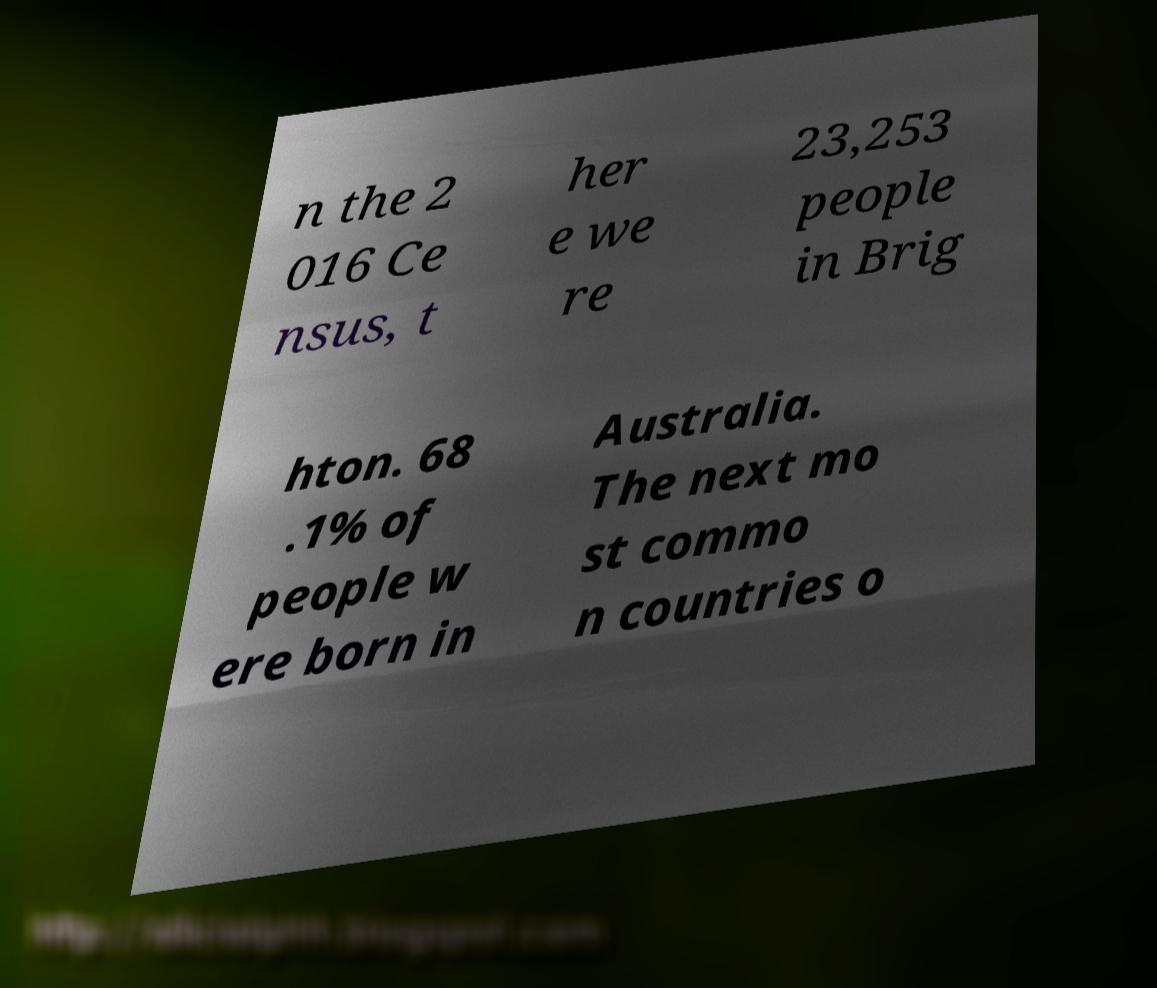Please identify and transcribe the text found in this image. n the 2 016 Ce nsus, t her e we re 23,253 people in Brig hton. 68 .1% of people w ere born in Australia. The next mo st commo n countries o 